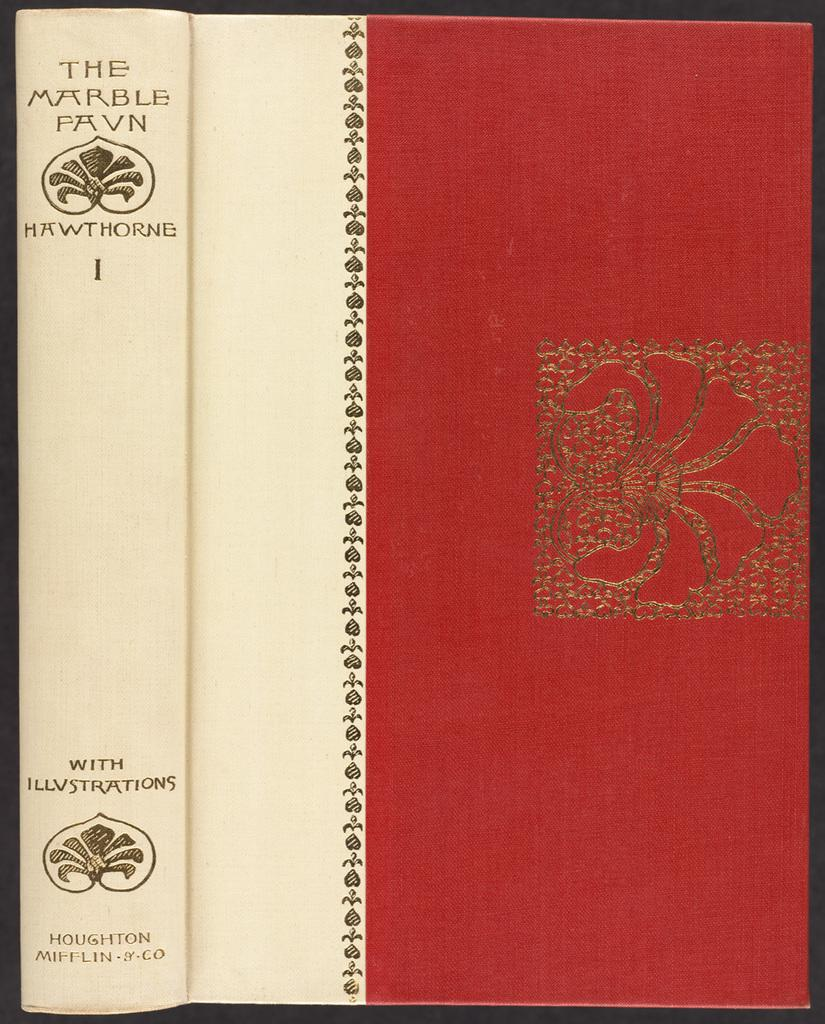<image>
Write a terse but informative summary of the picture. A red and white book called The Marble Pavn by Hawthorne. 